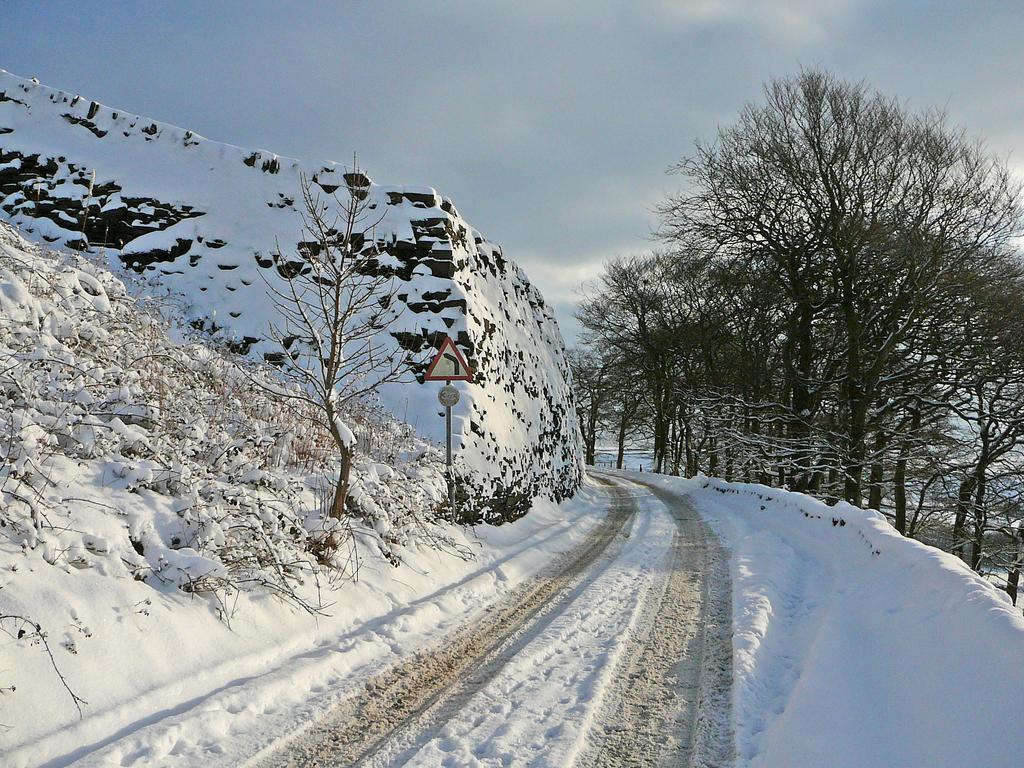Describe this image in one or two sentences. In this picture there are trees. On the left side of the image it looks like a hill and there is snow on the hill. At the top there are clouds. At the bottom is snow. 